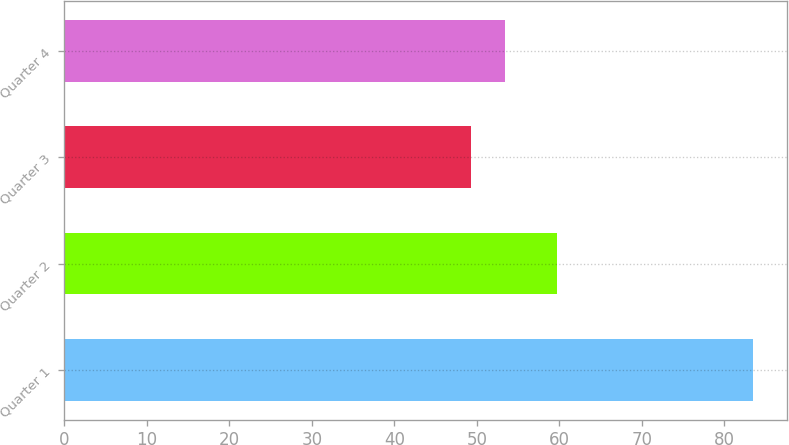Convert chart. <chart><loc_0><loc_0><loc_500><loc_500><bar_chart><fcel>Quarter 1<fcel>Quarter 2<fcel>Quarter 3<fcel>Quarter 4<nl><fcel>83.43<fcel>59.74<fcel>49.24<fcel>53.34<nl></chart> 